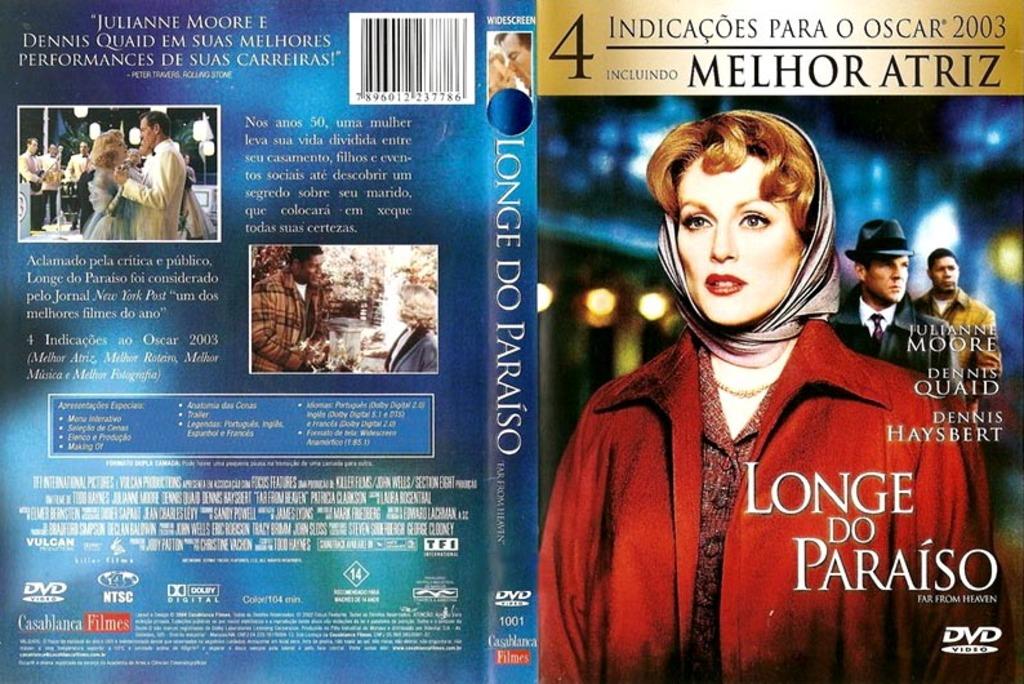What is the actress names listed first on the left page?
Offer a very short reply. Julianne moore. 